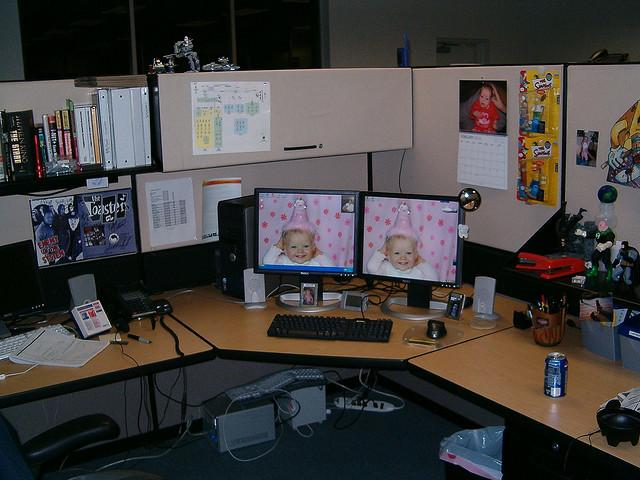Where is this desk setup? Please explain your reasoning. at work. This desk is set up inside a cubicle. there are personal belongings, so this building is not a library. 